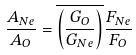Convert formula to latex. <formula><loc_0><loc_0><loc_500><loc_500>\frac { A _ { N e } } { A _ { O } } = \overline { \left ( \frac { G _ { O } } { G _ { N e } } \right ) } \frac { F _ { N e } } { F _ { O } }</formula> 